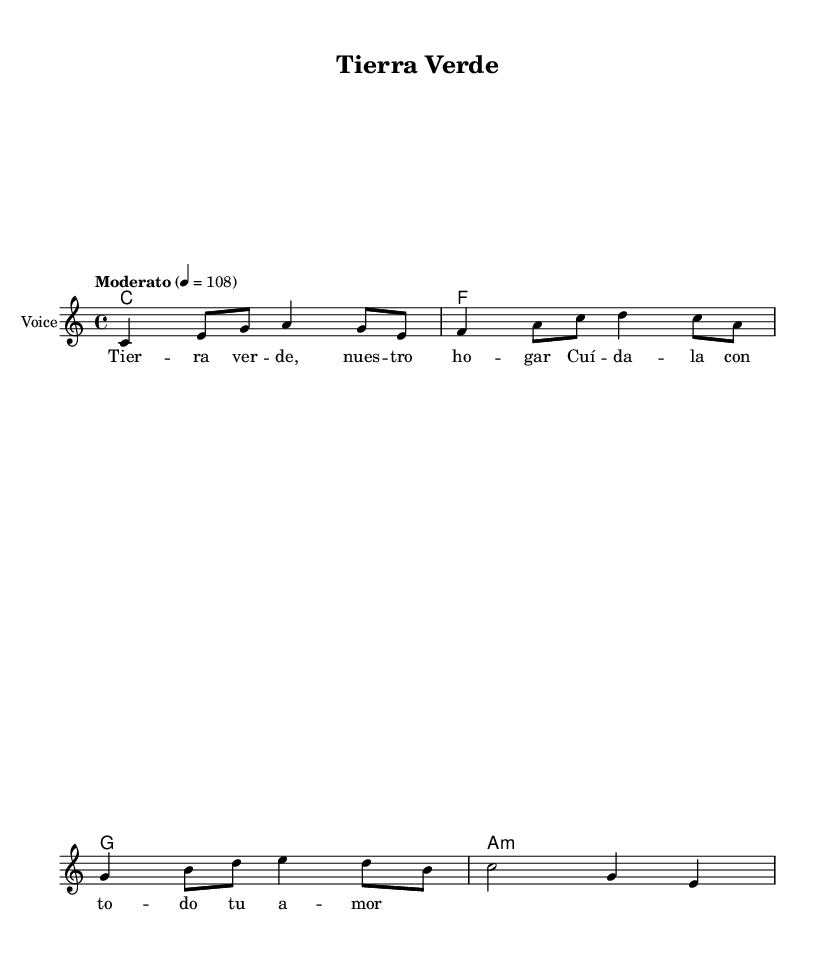What is the key signature of this music? The key signature is C major, which has no sharps or flats.
Answer: C major What is the time signature of this piece? The time signature provided is 4/4, which means there are four beats in each measure.
Answer: 4/4 What is the tempo marking of this music? The tempo marking indicates a moderate pace, specifically set at 108 beats per minute.
Answer: Moderato How many bars are in the melody? The melody consists of four distinct measures. Each measure contains a certain number of notes that form the line.
Answer: 4 What is the mood suggested by the harmony used in the music? The combination of chords (C, F, G, and A minor) tends to evoke a positive and uplifting mood, commonly found in Latin pop.
Answer: Uplifting What environmental theme is reflected in the lyrics? The lyrics encourage caring for the earth with love, highlighting an environmental message tied to sustainability.
Answer: Care for the earth How does the title "Tierra Verde" relate to the song's message? "Tierra Verde" translates to "Green Earth," which directly reflects the song's theme of promoting environmental awareness.
Answer: Green Earth 